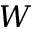<formula> <loc_0><loc_0><loc_500><loc_500>W</formula> 